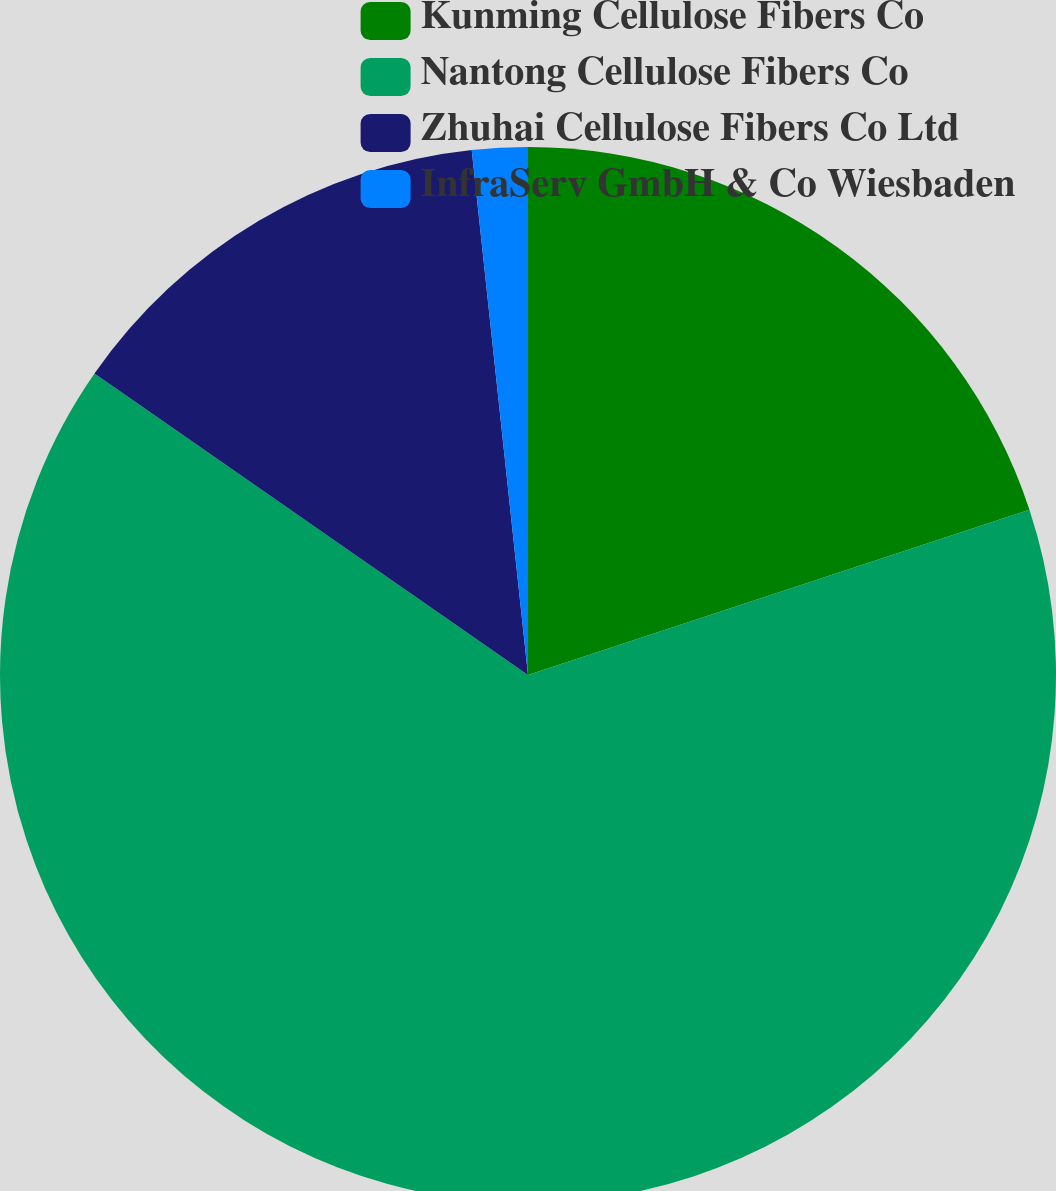Convert chart. <chart><loc_0><loc_0><loc_500><loc_500><pie_chart><fcel>Kunming Cellulose Fibers Co<fcel>Nantong Cellulose Fibers Co<fcel>Zhuhai Cellulose Fibers Co Ltd<fcel>InfraServ GmbH & Co Wiesbaden<nl><fcel>19.93%<fcel>64.74%<fcel>13.63%<fcel>1.7%<nl></chart> 